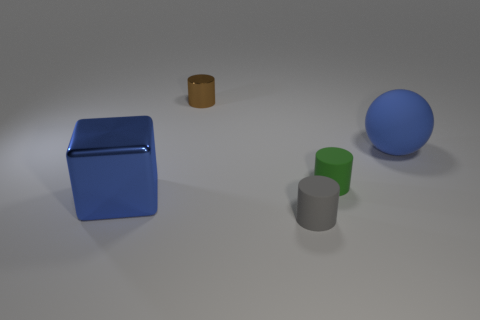Subtract all matte cylinders. How many cylinders are left? 1 Subtract all gray cylinders. How many cylinders are left? 2 Subtract all blocks. How many objects are left? 4 Add 5 large brown metal objects. How many objects exist? 10 Subtract 1 cubes. How many cubes are left? 0 Subtract all blue cylinders. Subtract all cyan blocks. How many cylinders are left? 3 Subtract all large rubber cylinders. Subtract all green things. How many objects are left? 4 Add 4 small brown cylinders. How many small brown cylinders are left? 5 Add 4 metallic cylinders. How many metallic cylinders exist? 5 Subtract 0 cyan cubes. How many objects are left? 5 